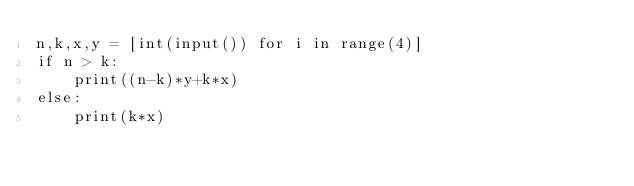<code> <loc_0><loc_0><loc_500><loc_500><_Python_>n,k,x,y = [int(input()) for i in range(4)]
if n > k:
    print((n-k)*y+k*x)
else:
    print(k*x)</code> 